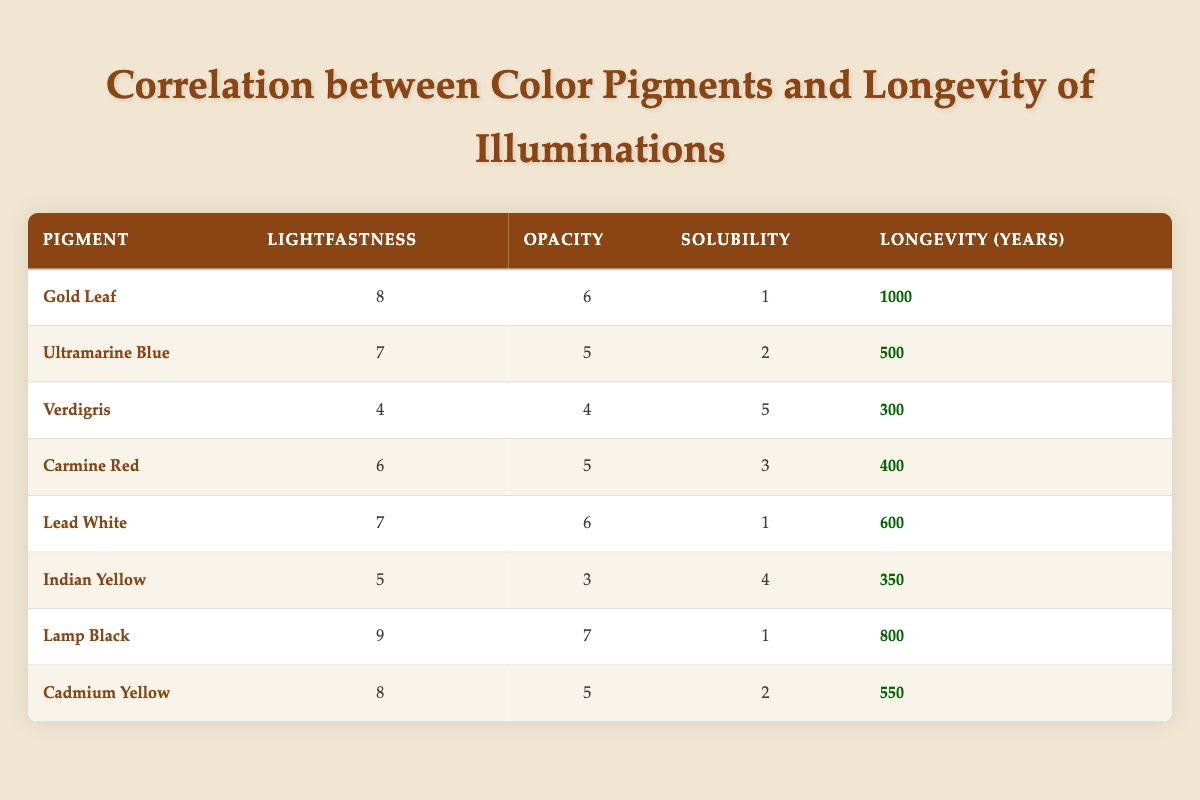What is the longevity of Gold Leaf? The table lists Gold Leaf as having a longevity rating of 1000 years, which can be found in the "Longevity (Years)" column of the row corresponding to Gold Leaf.
Answer: 1000 What is the lightfastness rating of Ultramarine Blue? The lightfastness rating for Ultramarine Blue is shown in the table as 7, located in the "Lightfastness" column of its respective row.
Answer: 7 Which pigment has the highest lightfastness score? By examining the lightfastness ratings in the table, we see that Lamp Black has the highest score of 9 in the "Lightfastness" column.
Answer: Lamp Black Is it true that Lead White has a higher longevity than Carmine Red? The longevity of Lead White is 600 years and Carmine Red is 400 years. Since 600 is greater than 400, the statement is true.
Answer: Yes What is the average longevity of the pigments listed? To find the average longevity, add all the longevity values together (1000 + 500 + 300 + 400 + 600 + 350 + 800 + 550 = 4100) and then divide by the number of pigments (8). Thus, 4100/8 = 512.5.
Answer: 512.5 Which pigment has the lowest solubility score, and what is that score? The "solubility" scores in the table indicate that Gold Leaf and Lamp Black both have a score of 1, which is the lowest. Therefore, both are correct answers.
Answer: Gold Leaf, Lamp Black: 1 What is the difference in longevity between the pigment with the highest longevity and the one with the lowest? The highest longevity is 1000 years (Gold Leaf), and the lowest is 300 years (Verdigris). The difference is 1000 - 300 = 700 years.
Answer: 700 How many pigments have a lightfastness rating above 6? By reviewing the "Lightfastness" column in the table, the pigments with scores above 6 are Gold Leaf (8), Lamp Black (9), and Cadmium Yellow (8), totaling to 3 pigments.
Answer: 3 